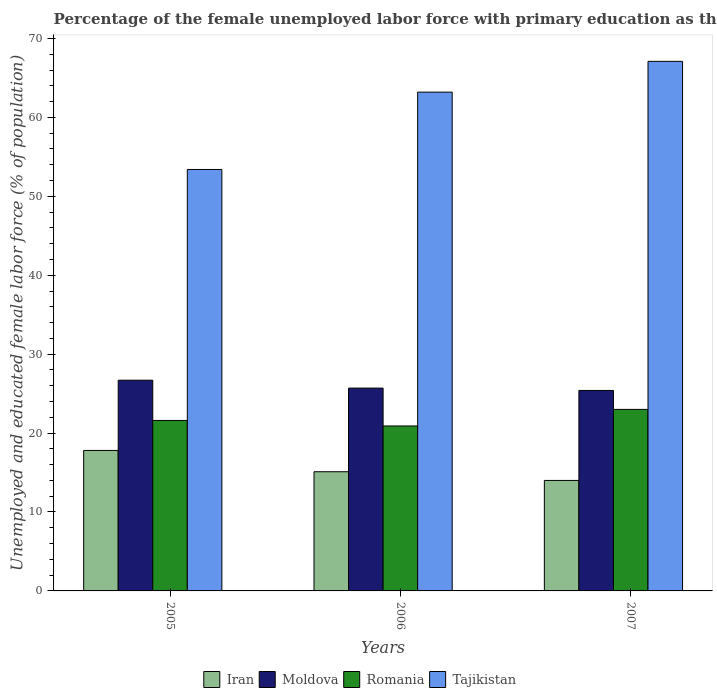How many groups of bars are there?
Make the answer very short. 3. Are the number of bars on each tick of the X-axis equal?
Provide a short and direct response. Yes. How many bars are there on the 1st tick from the left?
Provide a succinct answer. 4. How many bars are there on the 2nd tick from the right?
Offer a very short reply. 4. What is the percentage of the unemployed female labor force with primary education in Iran in 2005?
Your response must be concise. 17.8. Across all years, what is the maximum percentage of the unemployed female labor force with primary education in Romania?
Provide a short and direct response. 23. Across all years, what is the minimum percentage of the unemployed female labor force with primary education in Moldova?
Provide a succinct answer. 25.4. In which year was the percentage of the unemployed female labor force with primary education in Moldova minimum?
Your answer should be very brief. 2007. What is the total percentage of the unemployed female labor force with primary education in Moldova in the graph?
Make the answer very short. 77.8. What is the difference between the percentage of the unemployed female labor force with primary education in Tajikistan in 2005 and that in 2007?
Offer a very short reply. -13.7. What is the difference between the percentage of the unemployed female labor force with primary education in Moldova in 2007 and the percentage of the unemployed female labor force with primary education in Romania in 2006?
Provide a succinct answer. 4.5. What is the average percentage of the unemployed female labor force with primary education in Iran per year?
Give a very brief answer. 15.63. In the year 2007, what is the difference between the percentage of the unemployed female labor force with primary education in Moldova and percentage of the unemployed female labor force with primary education in Tajikistan?
Provide a succinct answer. -41.7. What is the ratio of the percentage of the unemployed female labor force with primary education in Iran in 2005 to that in 2006?
Your response must be concise. 1.18. What is the difference between the highest and the second highest percentage of the unemployed female labor force with primary education in Tajikistan?
Give a very brief answer. 3.9. What is the difference between the highest and the lowest percentage of the unemployed female labor force with primary education in Moldova?
Your response must be concise. 1.3. In how many years, is the percentage of the unemployed female labor force with primary education in Iran greater than the average percentage of the unemployed female labor force with primary education in Iran taken over all years?
Give a very brief answer. 1. Is the sum of the percentage of the unemployed female labor force with primary education in Iran in 2006 and 2007 greater than the maximum percentage of the unemployed female labor force with primary education in Moldova across all years?
Keep it short and to the point. Yes. What does the 3rd bar from the left in 2005 represents?
Offer a very short reply. Romania. What does the 1st bar from the right in 2007 represents?
Your response must be concise. Tajikistan. Is it the case that in every year, the sum of the percentage of the unemployed female labor force with primary education in Iran and percentage of the unemployed female labor force with primary education in Tajikistan is greater than the percentage of the unemployed female labor force with primary education in Romania?
Provide a short and direct response. Yes. How many bars are there?
Offer a terse response. 12. Are all the bars in the graph horizontal?
Your answer should be very brief. No. Does the graph contain any zero values?
Offer a terse response. No. Where does the legend appear in the graph?
Offer a terse response. Bottom center. How many legend labels are there?
Provide a succinct answer. 4. What is the title of the graph?
Your answer should be compact. Percentage of the female unemployed labor force with primary education as their highest grade. What is the label or title of the X-axis?
Keep it short and to the point. Years. What is the label or title of the Y-axis?
Give a very brief answer. Unemployed and educated female labor force (% of population). What is the Unemployed and educated female labor force (% of population) of Iran in 2005?
Give a very brief answer. 17.8. What is the Unemployed and educated female labor force (% of population) of Moldova in 2005?
Offer a very short reply. 26.7. What is the Unemployed and educated female labor force (% of population) of Romania in 2005?
Give a very brief answer. 21.6. What is the Unemployed and educated female labor force (% of population) of Tajikistan in 2005?
Your response must be concise. 53.4. What is the Unemployed and educated female labor force (% of population) of Iran in 2006?
Your answer should be very brief. 15.1. What is the Unemployed and educated female labor force (% of population) of Moldova in 2006?
Your response must be concise. 25.7. What is the Unemployed and educated female labor force (% of population) of Romania in 2006?
Your answer should be compact. 20.9. What is the Unemployed and educated female labor force (% of population) of Tajikistan in 2006?
Keep it short and to the point. 63.2. What is the Unemployed and educated female labor force (% of population) in Moldova in 2007?
Provide a succinct answer. 25.4. What is the Unemployed and educated female labor force (% of population) of Romania in 2007?
Provide a succinct answer. 23. What is the Unemployed and educated female labor force (% of population) in Tajikistan in 2007?
Your answer should be very brief. 67.1. Across all years, what is the maximum Unemployed and educated female labor force (% of population) of Iran?
Ensure brevity in your answer.  17.8. Across all years, what is the maximum Unemployed and educated female labor force (% of population) in Moldova?
Offer a terse response. 26.7. Across all years, what is the maximum Unemployed and educated female labor force (% of population) in Romania?
Your answer should be compact. 23. Across all years, what is the maximum Unemployed and educated female labor force (% of population) of Tajikistan?
Offer a very short reply. 67.1. Across all years, what is the minimum Unemployed and educated female labor force (% of population) in Iran?
Your answer should be compact. 14. Across all years, what is the minimum Unemployed and educated female labor force (% of population) of Moldova?
Your response must be concise. 25.4. Across all years, what is the minimum Unemployed and educated female labor force (% of population) of Romania?
Your response must be concise. 20.9. Across all years, what is the minimum Unemployed and educated female labor force (% of population) in Tajikistan?
Provide a short and direct response. 53.4. What is the total Unemployed and educated female labor force (% of population) in Iran in the graph?
Your response must be concise. 46.9. What is the total Unemployed and educated female labor force (% of population) in Moldova in the graph?
Offer a very short reply. 77.8. What is the total Unemployed and educated female labor force (% of population) of Romania in the graph?
Keep it short and to the point. 65.5. What is the total Unemployed and educated female labor force (% of population) in Tajikistan in the graph?
Provide a short and direct response. 183.7. What is the difference between the Unemployed and educated female labor force (% of population) in Iran in 2005 and that in 2006?
Offer a very short reply. 2.7. What is the difference between the Unemployed and educated female labor force (% of population) in Iran in 2005 and that in 2007?
Offer a very short reply. 3.8. What is the difference between the Unemployed and educated female labor force (% of population) of Moldova in 2005 and that in 2007?
Your response must be concise. 1.3. What is the difference between the Unemployed and educated female labor force (% of population) of Romania in 2005 and that in 2007?
Your answer should be compact. -1.4. What is the difference between the Unemployed and educated female labor force (% of population) in Tajikistan in 2005 and that in 2007?
Offer a very short reply. -13.7. What is the difference between the Unemployed and educated female labor force (% of population) of Moldova in 2006 and that in 2007?
Provide a succinct answer. 0.3. What is the difference between the Unemployed and educated female labor force (% of population) in Romania in 2006 and that in 2007?
Offer a very short reply. -2.1. What is the difference between the Unemployed and educated female labor force (% of population) in Iran in 2005 and the Unemployed and educated female labor force (% of population) in Tajikistan in 2006?
Your answer should be compact. -45.4. What is the difference between the Unemployed and educated female labor force (% of population) in Moldova in 2005 and the Unemployed and educated female labor force (% of population) in Tajikistan in 2006?
Give a very brief answer. -36.5. What is the difference between the Unemployed and educated female labor force (% of population) in Romania in 2005 and the Unemployed and educated female labor force (% of population) in Tajikistan in 2006?
Make the answer very short. -41.6. What is the difference between the Unemployed and educated female labor force (% of population) in Iran in 2005 and the Unemployed and educated female labor force (% of population) in Tajikistan in 2007?
Provide a short and direct response. -49.3. What is the difference between the Unemployed and educated female labor force (% of population) in Moldova in 2005 and the Unemployed and educated female labor force (% of population) in Tajikistan in 2007?
Ensure brevity in your answer.  -40.4. What is the difference between the Unemployed and educated female labor force (% of population) in Romania in 2005 and the Unemployed and educated female labor force (% of population) in Tajikistan in 2007?
Your answer should be compact. -45.5. What is the difference between the Unemployed and educated female labor force (% of population) of Iran in 2006 and the Unemployed and educated female labor force (% of population) of Moldova in 2007?
Ensure brevity in your answer.  -10.3. What is the difference between the Unemployed and educated female labor force (% of population) of Iran in 2006 and the Unemployed and educated female labor force (% of population) of Tajikistan in 2007?
Provide a short and direct response. -52. What is the difference between the Unemployed and educated female labor force (% of population) of Moldova in 2006 and the Unemployed and educated female labor force (% of population) of Tajikistan in 2007?
Ensure brevity in your answer.  -41.4. What is the difference between the Unemployed and educated female labor force (% of population) of Romania in 2006 and the Unemployed and educated female labor force (% of population) of Tajikistan in 2007?
Your response must be concise. -46.2. What is the average Unemployed and educated female labor force (% of population) of Iran per year?
Offer a terse response. 15.63. What is the average Unemployed and educated female labor force (% of population) in Moldova per year?
Make the answer very short. 25.93. What is the average Unemployed and educated female labor force (% of population) in Romania per year?
Offer a terse response. 21.83. What is the average Unemployed and educated female labor force (% of population) in Tajikistan per year?
Provide a short and direct response. 61.23. In the year 2005, what is the difference between the Unemployed and educated female labor force (% of population) in Iran and Unemployed and educated female labor force (% of population) in Romania?
Keep it short and to the point. -3.8. In the year 2005, what is the difference between the Unemployed and educated female labor force (% of population) of Iran and Unemployed and educated female labor force (% of population) of Tajikistan?
Provide a succinct answer. -35.6. In the year 2005, what is the difference between the Unemployed and educated female labor force (% of population) in Moldova and Unemployed and educated female labor force (% of population) in Romania?
Make the answer very short. 5.1. In the year 2005, what is the difference between the Unemployed and educated female labor force (% of population) of Moldova and Unemployed and educated female labor force (% of population) of Tajikistan?
Keep it short and to the point. -26.7. In the year 2005, what is the difference between the Unemployed and educated female labor force (% of population) of Romania and Unemployed and educated female labor force (% of population) of Tajikistan?
Keep it short and to the point. -31.8. In the year 2006, what is the difference between the Unemployed and educated female labor force (% of population) in Iran and Unemployed and educated female labor force (% of population) in Tajikistan?
Your answer should be compact. -48.1. In the year 2006, what is the difference between the Unemployed and educated female labor force (% of population) of Moldova and Unemployed and educated female labor force (% of population) of Tajikistan?
Your response must be concise. -37.5. In the year 2006, what is the difference between the Unemployed and educated female labor force (% of population) in Romania and Unemployed and educated female labor force (% of population) in Tajikistan?
Your response must be concise. -42.3. In the year 2007, what is the difference between the Unemployed and educated female labor force (% of population) of Iran and Unemployed and educated female labor force (% of population) of Romania?
Your response must be concise. -9. In the year 2007, what is the difference between the Unemployed and educated female labor force (% of population) in Iran and Unemployed and educated female labor force (% of population) in Tajikistan?
Keep it short and to the point. -53.1. In the year 2007, what is the difference between the Unemployed and educated female labor force (% of population) of Moldova and Unemployed and educated female labor force (% of population) of Romania?
Your answer should be compact. 2.4. In the year 2007, what is the difference between the Unemployed and educated female labor force (% of population) in Moldova and Unemployed and educated female labor force (% of population) in Tajikistan?
Offer a very short reply. -41.7. In the year 2007, what is the difference between the Unemployed and educated female labor force (% of population) of Romania and Unemployed and educated female labor force (% of population) of Tajikistan?
Provide a succinct answer. -44.1. What is the ratio of the Unemployed and educated female labor force (% of population) in Iran in 2005 to that in 2006?
Provide a short and direct response. 1.18. What is the ratio of the Unemployed and educated female labor force (% of population) of Moldova in 2005 to that in 2006?
Ensure brevity in your answer.  1.04. What is the ratio of the Unemployed and educated female labor force (% of population) of Romania in 2005 to that in 2006?
Offer a very short reply. 1.03. What is the ratio of the Unemployed and educated female labor force (% of population) of Tajikistan in 2005 to that in 2006?
Your response must be concise. 0.84. What is the ratio of the Unemployed and educated female labor force (% of population) in Iran in 2005 to that in 2007?
Provide a succinct answer. 1.27. What is the ratio of the Unemployed and educated female labor force (% of population) in Moldova in 2005 to that in 2007?
Give a very brief answer. 1.05. What is the ratio of the Unemployed and educated female labor force (% of population) of Romania in 2005 to that in 2007?
Offer a terse response. 0.94. What is the ratio of the Unemployed and educated female labor force (% of population) in Tajikistan in 2005 to that in 2007?
Your answer should be compact. 0.8. What is the ratio of the Unemployed and educated female labor force (% of population) of Iran in 2006 to that in 2007?
Your answer should be very brief. 1.08. What is the ratio of the Unemployed and educated female labor force (% of population) of Moldova in 2006 to that in 2007?
Keep it short and to the point. 1.01. What is the ratio of the Unemployed and educated female labor force (% of population) of Romania in 2006 to that in 2007?
Your answer should be very brief. 0.91. What is the ratio of the Unemployed and educated female labor force (% of population) in Tajikistan in 2006 to that in 2007?
Provide a succinct answer. 0.94. What is the difference between the highest and the lowest Unemployed and educated female labor force (% of population) of Romania?
Provide a succinct answer. 2.1. What is the difference between the highest and the lowest Unemployed and educated female labor force (% of population) in Tajikistan?
Make the answer very short. 13.7. 